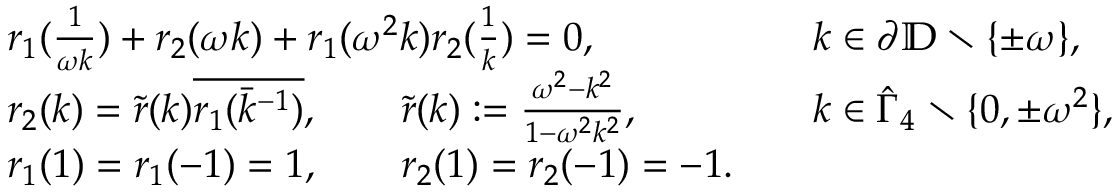<formula> <loc_0><loc_0><loc_500><loc_500>\begin{array} { r l r l } & { r _ { 1 } ( \frac { 1 } { \omega k } ) + r _ { 2 } ( \omega k ) + r _ { 1 } ( \omega ^ { 2 } k ) r _ { 2 } ( \frac { 1 } { k } ) = 0 , } & & { k \in \partial { \mathbb { D } } \ \{ \pm \omega \} , } \\ & { r _ { 2 } ( k ) = \tilde { r } ( k ) \overline { { r _ { 1 } ( \bar { k } ^ { - 1 } ) } } , \quad \tilde { r } ( k ) \colon = \frac { \omega ^ { 2 } - k ^ { 2 } } { 1 - \omega ^ { 2 } k ^ { 2 } } , } & & { k \in \hat { \Gamma } _ { 4 } \ \{ 0 , \pm \omega ^ { 2 } \} , } \\ & { r _ { 1 } ( 1 ) = r _ { 1 } ( - 1 ) = 1 , \quad r _ { 2 } ( 1 ) = r _ { 2 } ( - 1 ) = - 1 . } \end{array}</formula> 